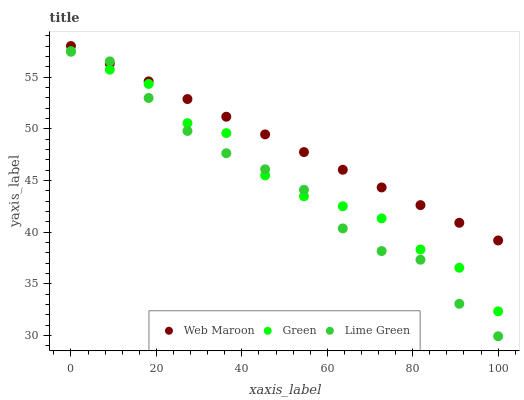Does Lime Green have the minimum area under the curve?
Answer yes or no. Yes. Does Web Maroon have the maximum area under the curve?
Answer yes or no. Yes. Does Web Maroon have the minimum area under the curve?
Answer yes or no. No. Does Lime Green have the maximum area under the curve?
Answer yes or no. No. Is Web Maroon the smoothest?
Answer yes or no. Yes. Is Green the roughest?
Answer yes or no. Yes. Is Lime Green the smoothest?
Answer yes or no. No. Is Lime Green the roughest?
Answer yes or no. No. Does Lime Green have the lowest value?
Answer yes or no. Yes. Does Web Maroon have the lowest value?
Answer yes or no. No. Does Web Maroon have the highest value?
Answer yes or no. Yes. Does Lime Green have the highest value?
Answer yes or no. No. Is Green less than Web Maroon?
Answer yes or no. Yes. Is Web Maroon greater than Green?
Answer yes or no. Yes. Does Lime Green intersect Green?
Answer yes or no. Yes. Is Lime Green less than Green?
Answer yes or no. No. Is Lime Green greater than Green?
Answer yes or no. No. Does Green intersect Web Maroon?
Answer yes or no. No. 